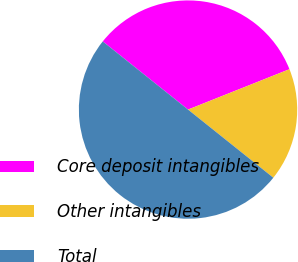Convert chart to OTSL. <chart><loc_0><loc_0><loc_500><loc_500><pie_chart><fcel>Core deposit intangibles<fcel>Other intangibles<fcel>Total<nl><fcel>33.24%<fcel>16.76%<fcel>50.0%<nl></chart> 